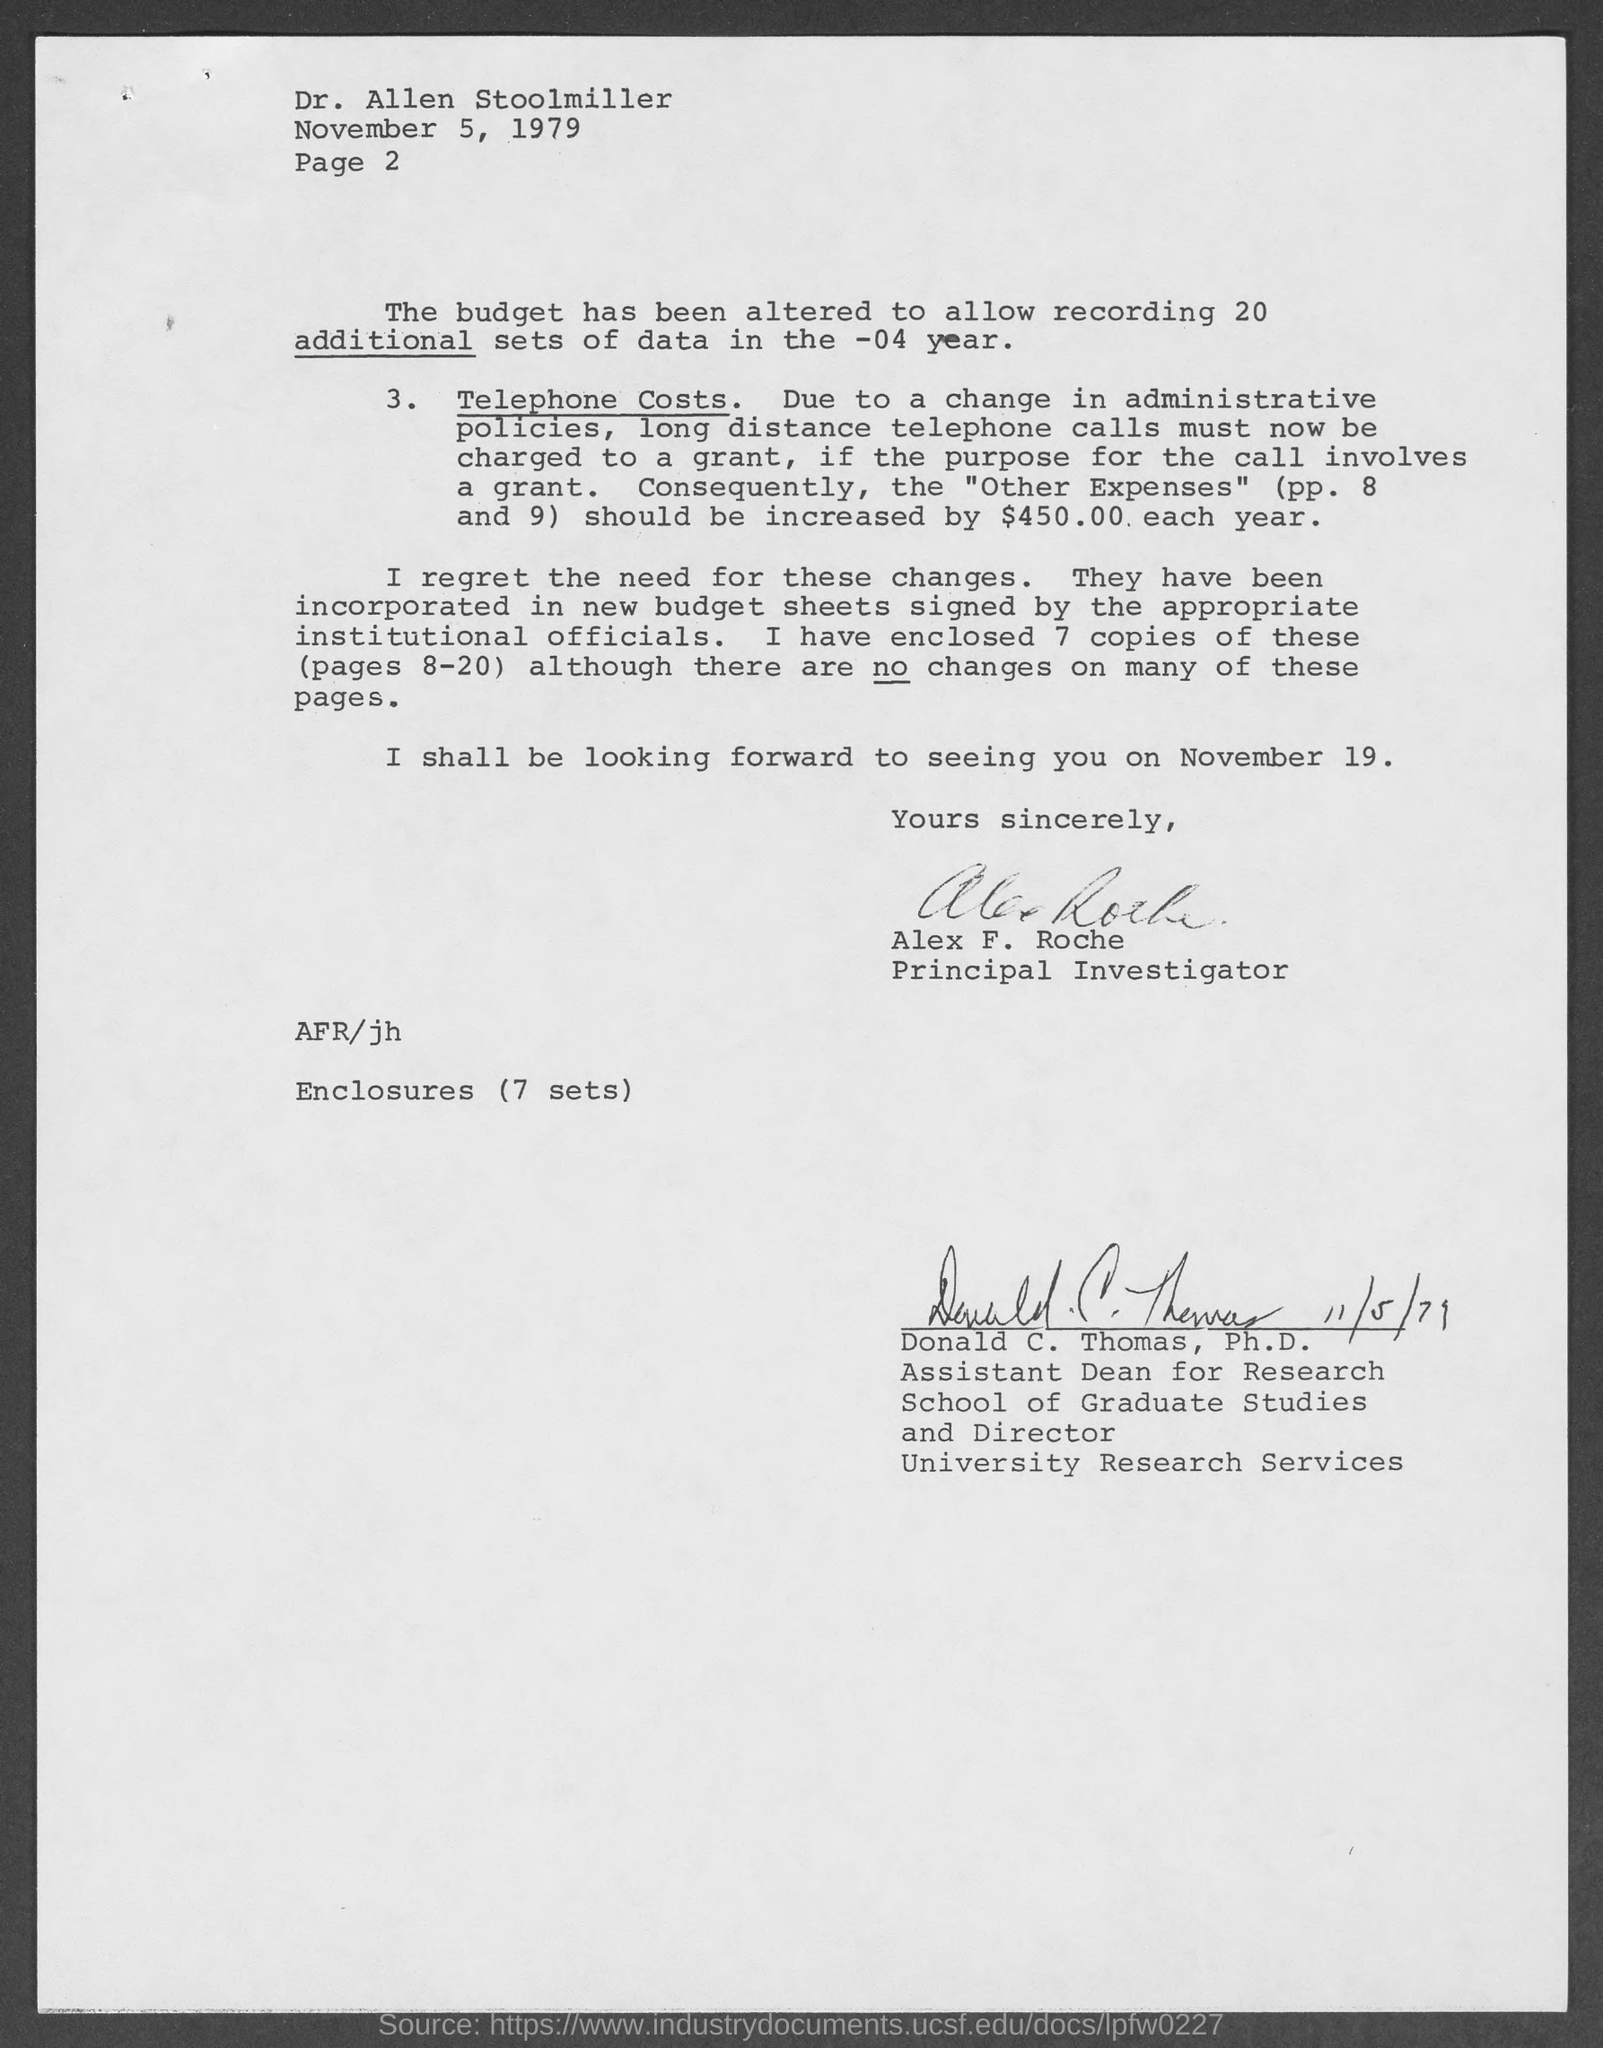Give some essential details in this illustration. The letter is from a person named Alex F. Roche. When is the meeting with him scheduled for? November 19.. The letter is addressed to Dr. Allen Stoolmiller. The document indicates that the date is November 5, 1979. 